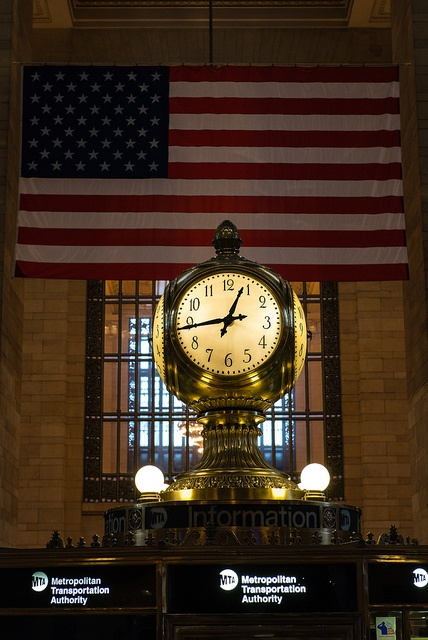Describe the objects in this image and their specific colors. I can see clock in black, khaki, tan, and lightyellow tones and clock in black, gold, and khaki tones in this image. 